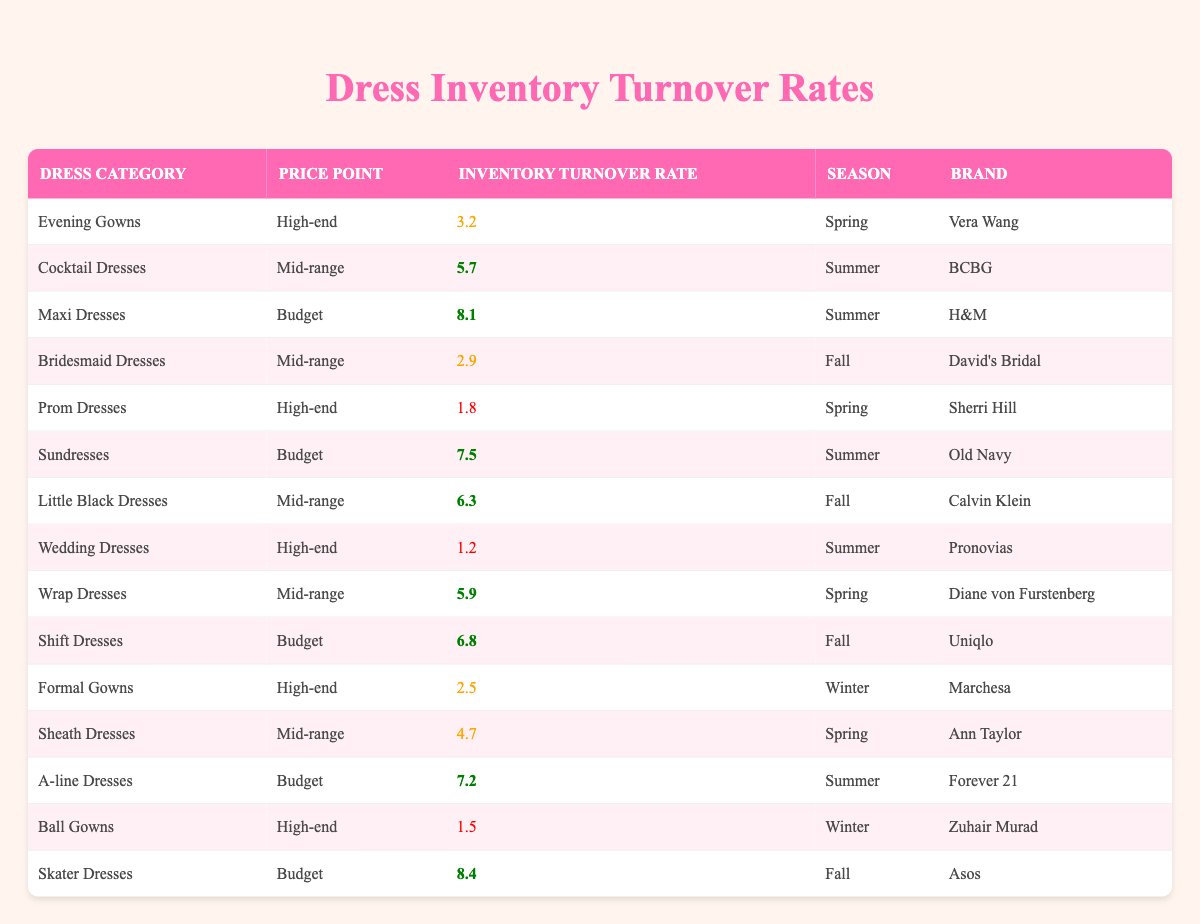What's the highest inventory turnover rate among budget-priced dresses? From the table, the budget-priced dress with the highest inventory turnover rate is the Skater Dress at 8.4, which can be identified clearly in the list of budget dresses.
Answer: 8.4 Which dress category has the lowest inventory turnover rate? By examining the inventory turnover rates, the Wedding Dress has the lowest rate at 1.2, making it the category with the lowest turnover in the table.
Answer: Wedding Dresses What is the average inventory turnover rate for mid-range dresses? The mid-range dresses' inventory turnover rates are 5.7, 2.9, 6.3, 5.9, and 4.7. Adding these up gives 25.5 and dividing by 5 (the number of mid-range dresses) results in an average of 5.1.
Answer: 5.1 Are there any high-end dresses with an inventory turnover rate greater than 2.5? Yes, both the Evening Gowns (3.2) and the Cocktail Dresses (5.7) have inventory turnover rates greater than 2.5, which can be verified by comparing the values in their respective rows.
Answer: Yes How many budget dresses have an inventory turnover rate above 7.0? The Skater Dress (8.4), Maxi Dress (8.1), and Sundress (7.5) all exceed 7.0, giving a total of three budget dresses that meet this criteria upon counting them from the table data.
Answer: 3 What is the difference between the highest and lowest inventory turnover rates for high-end dresses? The highest inventory turnover rate for high-end dresses is 3.2 (Evening Gowns) and the lowest is 1.2 (Wedding Dresses). The difference is calculated as 3.2 - 1.2 = 2.0.
Answer: 2.0 Which price point has the highest average inventory turnover rate? The turnover rates for high-end dresses average to (3.2 + 1.8 + 1.2 + 2.5 + 1.5) = 10.2, divided by 5 equals 2.04. Mid-range dresses average at 5.1, and budget dresses average at 7.2. The budget dresses have the highest average turnover rate.
Answer: Budget Do any dresses in the table have an inventory turnover rate below 2.0? Yes, the Ball Gowns (1.5) and Wedding Dresses (1.2) both have turnover rates that fall below 2.0, indicated by their values in the respective rows of the table.
Answer: Yes What season has the most dresses with inventory turnover rates classified as high? By analyzing the entries, Summer has the Maxi Dresses, Sundresses, and Cocktail Dresses, which are high turnover. Fall also has the Skater Dress and the Shift Dress, thus Summer has more high turnover dresses.
Answer: Summer 